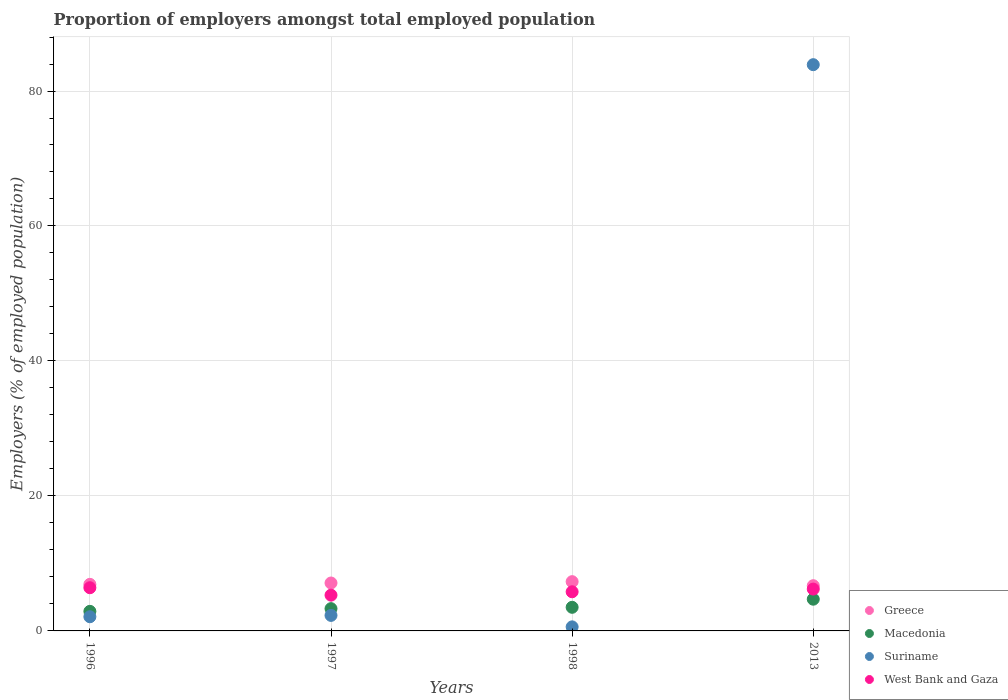What is the proportion of employers in Macedonia in 2013?
Give a very brief answer. 4.7. Across all years, what is the maximum proportion of employers in West Bank and Gaza?
Give a very brief answer. 6.4. Across all years, what is the minimum proportion of employers in West Bank and Gaza?
Keep it short and to the point. 5.3. In which year was the proportion of employers in West Bank and Gaza minimum?
Provide a succinct answer. 1997. What is the total proportion of employers in Suriname in the graph?
Your response must be concise. 88.9. What is the difference between the proportion of employers in Macedonia in 1997 and that in 1998?
Make the answer very short. -0.2. What is the difference between the proportion of employers in West Bank and Gaza in 1998 and the proportion of employers in Suriname in 1997?
Offer a very short reply. 3.5. What is the average proportion of employers in Greece per year?
Make the answer very short. 7. In the year 1998, what is the difference between the proportion of employers in West Bank and Gaza and proportion of employers in Suriname?
Your answer should be compact. 5.2. In how many years, is the proportion of employers in Greece greater than 44 %?
Your answer should be very brief. 0. What is the ratio of the proportion of employers in Macedonia in 1996 to that in 1997?
Make the answer very short. 0.88. Is the proportion of employers in Suriname in 1996 less than that in 2013?
Make the answer very short. Yes. What is the difference between the highest and the second highest proportion of employers in Suriname?
Your answer should be compact. 81.6. What is the difference between the highest and the lowest proportion of employers in West Bank and Gaza?
Ensure brevity in your answer.  1.1. In how many years, is the proportion of employers in West Bank and Gaza greater than the average proportion of employers in West Bank and Gaza taken over all years?
Your answer should be compact. 2. Does the proportion of employers in West Bank and Gaza monotonically increase over the years?
Provide a short and direct response. No. Is the proportion of employers in Greece strictly greater than the proportion of employers in Macedonia over the years?
Keep it short and to the point. Yes. How many years are there in the graph?
Make the answer very short. 4. Does the graph contain any zero values?
Make the answer very short. No. Does the graph contain grids?
Ensure brevity in your answer.  Yes. Where does the legend appear in the graph?
Your answer should be compact. Bottom right. How many legend labels are there?
Provide a short and direct response. 4. What is the title of the graph?
Give a very brief answer. Proportion of employers amongst total employed population. Does "Somalia" appear as one of the legend labels in the graph?
Provide a short and direct response. No. What is the label or title of the X-axis?
Ensure brevity in your answer.  Years. What is the label or title of the Y-axis?
Provide a succinct answer. Employers (% of employed population). What is the Employers (% of employed population) of Greece in 1996?
Ensure brevity in your answer.  6.9. What is the Employers (% of employed population) in Macedonia in 1996?
Make the answer very short. 2.9. What is the Employers (% of employed population) in Suriname in 1996?
Your response must be concise. 2.1. What is the Employers (% of employed population) in West Bank and Gaza in 1996?
Provide a succinct answer. 6.4. What is the Employers (% of employed population) in Greece in 1997?
Offer a very short reply. 7.1. What is the Employers (% of employed population) of Macedonia in 1997?
Give a very brief answer. 3.3. What is the Employers (% of employed population) in Suriname in 1997?
Offer a very short reply. 2.3. What is the Employers (% of employed population) of West Bank and Gaza in 1997?
Your answer should be compact. 5.3. What is the Employers (% of employed population) in Greece in 1998?
Offer a terse response. 7.3. What is the Employers (% of employed population) in Macedonia in 1998?
Your answer should be very brief. 3.5. What is the Employers (% of employed population) of Suriname in 1998?
Your response must be concise. 0.6. What is the Employers (% of employed population) of West Bank and Gaza in 1998?
Offer a terse response. 5.8. What is the Employers (% of employed population) of Greece in 2013?
Keep it short and to the point. 6.7. What is the Employers (% of employed population) in Macedonia in 2013?
Your response must be concise. 4.7. What is the Employers (% of employed population) in Suriname in 2013?
Your response must be concise. 83.9. What is the Employers (% of employed population) in West Bank and Gaza in 2013?
Your response must be concise. 6.2. Across all years, what is the maximum Employers (% of employed population) of Greece?
Offer a very short reply. 7.3. Across all years, what is the maximum Employers (% of employed population) of Macedonia?
Your answer should be compact. 4.7. Across all years, what is the maximum Employers (% of employed population) in Suriname?
Your answer should be very brief. 83.9. Across all years, what is the maximum Employers (% of employed population) of West Bank and Gaza?
Make the answer very short. 6.4. Across all years, what is the minimum Employers (% of employed population) in Greece?
Your answer should be very brief. 6.7. Across all years, what is the minimum Employers (% of employed population) in Macedonia?
Ensure brevity in your answer.  2.9. Across all years, what is the minimum Employers (% of employed population) of Suriname?
Your answer should be compact. 0.6. Across all years, what is the minimum Employers (% of employed population) in West Bank and Gaza?
Offer a terse response. 5.3. What is the total Employers (% of employed population) of Greece in the graph?
Provide a succinct answer. 28. What is the total Employers (% of employed population) in Suriname in the graph?
Offer a terse response. 88.9. What is the total Employers (% of employed population) in West Bank and Gaza in the graph?
Your response must be concise. 23.7. What is the difference between the Employers (% of employed population) of Greece in 1996 and that in 1997?
Your response must be concise. -0.2. What is the difference between the Employers (% of employed population) of Macedonia in 1996 and that in 1997?
Ensure brevity in your answer.  -0.4. What is the difference between the Employers (% of employed population) of West Bank and Gaza in 1996 and that in 1997?
Give a very brief answer. 1.1. What is the difference between the Employers (% of employed population) in Greece in 1996 and that in 1998?
Provide a succinct answer. -0.4. What is the difference between the Employers (% of employed population) in Macedonia in 1996 and that in 1998?
Your response must be concise. -0.6. What is the difference between the Employers (% of employed population) in Greece in 1996 and that in 2013?
Ensure brevity in your answer.  0.2. What is the difference between the Employers (% of employed population) of Macedonia in 1996 and that in 2013?
Offer a very short reply. -1.8. What is the difference between the Employers (% of employed population) in Suriname in 1996 and that in 2013?
Your response must be concise. -81.8. What is the difference between the Employers (% of employed population) of West Bank and Gaza in 1996 and that in 2013?
Make the answer very short. 0.2. What is the difference between the Employers (% of employed population) of Greece in 1997 and that in 1998?
Make the answer very short. -0.2. What is the difference between the Employers (% of employed population) in Macedonia in 1997 and that in 1998?
Your response must be concise. -0.2. What is the difference between the Employers (% of employed population) in West Bank and Gaza in 1997 and that in 1998?
Make the answer very short. -0.5. What is the difference between the Employers (% of employed population) in Greece in 1997 and that in 2013?
Your response must be concise. 0.4. What is the difference between the Employers (% of employed population) in Macedonia in 1997 and that in 2013?
Ensure brevity in your answer.  -1.4. What is the difference between the Employers (% of employed population) of Suriname in 1997 and that in 2013?
Provide a succinct answer. -81.6. What is the difference between the Employers (% of employed population) of West Bank and Gaza in 1997 and that in 2013?
Your answer should be compact. -0.9. What is the difference between the Employers (% of employed population) in Macedonia in 1998 and that in 2013?
Ensure brevity in your answer.  -1.2. What is the difference between the Employers (% of employed population) in Suriname in 1998 and that in 2013?
Ensure brevity in your answer.  -83.3. What is the difference between the Employers (% of employed population) in Greece in 1996 and the Employers (% of employed population) in Macedonia in 1998?
Offer a terse response. 3.4. What is the difference between the Employers (% of employed population) in Greece in 1996 and the Employers (% of employed population) in Suriname in 1998?
Your answer should be compact. 6.3. What is the difference between the Employers (% of employed population) in Greece in 1996 and the Employers (% of employed population) in West Bank and Gaza in 1998?
Keep it short and to the point. 1.1. What is the difference between the Employers (% of employed population) in Macedonia in 1996 and the Employers (% of employed population) in West Bank and Gaza in 1998?
Offer a very short reply. -2.9. What is the difference between the Employers (% of employed population) in Suriname in 1996 and the Employers (% of employed population) in West Bank and Gaza in 1998?
Ensure brevity in your answer.  -3.7. What is the difference between the Employers (% of employed population) of Greece in 1996 and the Employers (% of employed population) of Suriname in 2013?
Your response must be concise. -77. What is the difference between the Employers (% of employed population) in Greece in 1996 and the Employers (% of employed population) in West Bank and Gaza in 2013?
Offer a very short reply. 0.7. What is the difference between the Employers (% of employed population) of Macedonia in 1996 and the Employers (% of employed population) of Suriname in 2013?
Offer a very short reply. -81. What is the difference between the Employers (% of employed population) in Greece in 1997 and the Employers (% of employed population) in Suriname in 1998?
Your response must be concise. 6.5. What is the difference between the Employers (% of employed population) in Greece in 1997 and the Employers (% of employed population) in West Bank and Gaza in 1998?
Your answer should be very brief. 1.3. What is the difference between the Employers (% of employed population) in Macedonia in 1997 and the Employers (% of employed population) in Suriname in 1998?
Offer a very short reply. 2.7. What is the difference between the Employers (% of employed population) of Macedonia in 1997 and the Employers (% of employed population) of West Bank and Gaza in 1998?
Offer a terse response. -2.5. What is the difference between the Employers (% of employed population) of Suriname in 1997 and the Employers (% of employed population) of West Bank and Gaza in 1998?
Ensure brevity in your answer.  -3.5. What is the difference between the Employers (% of employed population) in Greece in 1997 and the Employers (% of employed population) in Suriname in 2013?
Provide a short and direct response. -76.8. What is the difference between the Employers (% of employed population) of Macedonia in 1997 and the Employers (% of employed population) of Suriname in 2013?
Give a very brief answer. -80.6. What is the difference between the Employers (% of employed population) in Macedonia in 1997 and the Employers (% of employed population) in West Bank and Gaza in 2013?
Offer a terse response. -2.9. What is the difference between the Employers (% of employed population) of Greece in 1998 and the Employers (% of employed population) of Suriname in 2013?
Provide a short and direct response. -76.6. What is the difference between the Employers (% of employed population) in Macedonia in 1998 and the Employers (% of employed population) in Suriname in 2013?
Your response must be concise. -80.4. What is the difference between the Employers (% of employed population) in Suriname in 1998 and the Employers (% of employed population) in West Bank and Gaza in 2013?
Offer a very short reply. -5.6. What is the average Employers (% of employed population) of Macedonia per year?
Provide a short and direct response. 3.6. What is the average Employers (% of employed population) of Suriname per year?
Make the answer very short. 22.23. What is the average Employers (% of employed population) of West Bank and Gaza per year?
Ensure brevity in your answer.  5.92. In the year 1996, what is the difference between the Employers (% of employed population) in Greece and Employers (% of employed population) in Suriname?
Make the answer very short. 4.8. In the year 1996, what is the difference between the Employers (% of employed population) in Greece and Employers (% of employed population) in West Bank and Gaza?
Offer a terse response. 0.5. In the year 1996, what is the difference between the Employers (% of employed population) of Macedonia and Employers (% of employed population) of Suriname?
Provide a succinct answer. 0.8. In the year 1996, what is the difference between the Employers (% of employed population) in Macedonia and Employers (% of employed population) in West Bank and Gaza?
Offer a very short reply. -3.5. In the year 1996, what is the difference between the Employers (% of employed population) in Suriname and Employers (% of employed population) in West Bank and Gaza?
Your answer should be compact. -4.3. In the year 1997, what is the difference between the Employers (% of employed population) of Greece and Employers (% of employed population) of Macedonia?
Your answer should be compact. 3.8. In the year 1997, what is the difference between the Employers (% of employed population) in Greece and Employers (% of employed population) in West Bank and Gaza?
Ensure brevity in your answer.  1.8. In the year 1998, what is the difference between the Employers (% of employed population) of Greece and Employers (% of employed population) of Suriname?
Offer a terse response. 6.7. In the year 1998, what is the difference between the Employers (% of employed population) in Greece and Employers (% of employed population) in West Bank and Gaza?
Provide a short and direct response. 1.5. In the year 1998, what is the difference between the Employers (% of employed population) of Macedonia and Employers (% of employed population) of Suriname?
Offer a very short reply. 2.9. In the year 1998, what is the difference between the Employers (% of employed population) of Macedonia and Employers (% of employed population) of West Bank and Gaza?
Make the answer very short. -2.3. In the year 2013, what is the difference between the Employers (% of employed population) in Greece and Employers (% of employed population) in Macedonia?
Provide a succinct answer. 2. In the year 2013, what is the difference between the Employers (% of employed population) of Greece and Employers (% of employed population) of Suriname?
Provide a short and direct response. -77.2. In the year 2013, what is the difference between the Employers (% of employed population) of Greece and Employers (% of employed population) of West Bank and Gaza?
Your answer should be very brief. 0.5. In the year 2013, what is the difference between the Employers (% of employed population) of Macedonia and Employers (% of employed population) of Suriname?
Your answer should be very brief. -79.2. In the year 2013, what is the difference between the Employers (% of employed population) of Macedonia and Employers (% of employed population) of West Bank and Gaza?
Offer a terse response. -1.5. In the year 2013, what is the difference between the Employers (% of employed population) in Suriname and Employers (% of employed population) in West Bank and Gaza?
Give a very brief answer. 77.7. What is the ratio of the Employers (% of employed population) in Greece in 1996 to that in 1997?
Offer a terse response. 0.97. What is the ratio of the Employers (% of employed population) in Macedonia in 1996 to that in 1997?
Give a very brief answer. 0.88. What is the ratio of the Employers (% of employed population) in West Bank and Gaza in 1996 to that in 1997?
Your response must be concise. 1.21. What is the ratio of the Employers (% of employed population) of Greece in 1996 to that in 1998?
Provide a succinct answer. 0.95. What is the ratio of the Employers (% of employed population) of Macedonia in 1996 to that in 1998?
Ensure brevity in your answer.  0.83. What is the ratio of the Employers (% of employed population) in West Bank and Gaza in 1996 to that in 1998?
Ensure brevity in your answer.  1.1. What is the ratio of the Employers (% of employed population) in Greece in 1996 to that in 2013?
Provide a succinct answer. 1.03. What is the ratio of the Employers (% of employed population) in Macedonia in 1996 to that in 2013?
Provide a short and direct response. 0.62. What is the ratio of the Employers (% of employed population) of Suriname in 1996 to that in 2013?
Your answer should be compact. 0.03. What is the ratio of the Employers (% of employed population) of West Bank and Gaza in 1996 to that in 2013?
Give a very brief answer. 1.03. What is the ratio of the Employers (% of employed population) in Greece in 1997 to that in 1998?
Provide a short and direct response. 0.97. What is the ratio of the Employers (% of employed population) of Macedonia in 1997 to that in 1998?
Keep it short and to the point. 0.94. What is the ratio of the Employers (% of employed population) of Suriname in 1997 to that in 1998?
Offer a terse response. 3.83. What is the ratio of the Employers (% of employed population) in West Bank and Gaza in 1997 to that in 1998?
Ensure brevity in your answer.  0.91. What is the ratio of the Employers (% of employed population) of Greece in 1997 to that in 2013?
Your response must be concise. 1.06. What is the ratio of the Employers (% of employed population) in Macedonia in 1997 to that in 2013?
Offer a terse response. 0.7. What is the ratio of the Employers (% of employed population) of Suriname in 1997 to that in 2013?
Offer a very short reply. 0.03. What is the ratio of the Employers (% of employed population) of West Bank and Gaza in 1997 to that in 2013?
Offer a terse response. 0.85. What is the ratio of the Employers (% of employed population) in Greece in 1998 to that in 2013?
Ensure brevity in your answer.  1.09. What is the ratio of the Employers (% of employed population) of Macedonia in 1998 to that in 2013?
Your answer should be compact. 0.74. What is the ratio of the Employers (% of employed population) in Suriname in 1998 to that in 2013?
Offer a very short reply. 0.01. What is the ratio of the Employers (% of employed population) of West Bank and Gaza in 1998 to that in 2013?
Provide a short and direct response. 0.94. What is the difference between the highest and the second highest Employers (% of employed population) of Greece?
Offer a very short reply. 0.2. What is the difference between the highest and the second highest Employers (% of employed population) in Suriname?
Your answer should be very brief. 81.6. What is the difference between the highest and the lowest Employers (% of employed population) of Greece?
Your answer should be compact. 0.6. What is the difference between the highest and the lowest Employers (% of employed population) in Macedonia?
Ensure brevity in your answer.  1.8. What is the difference between the highest and the lowest Employers (% of employed population) of Suriname?
Your response must be concise. 83.3. What is the difference between the highest and the lowest Employers (% of employed population) of West Bank and Gaza?
Your answer should be compact. 1.1. 